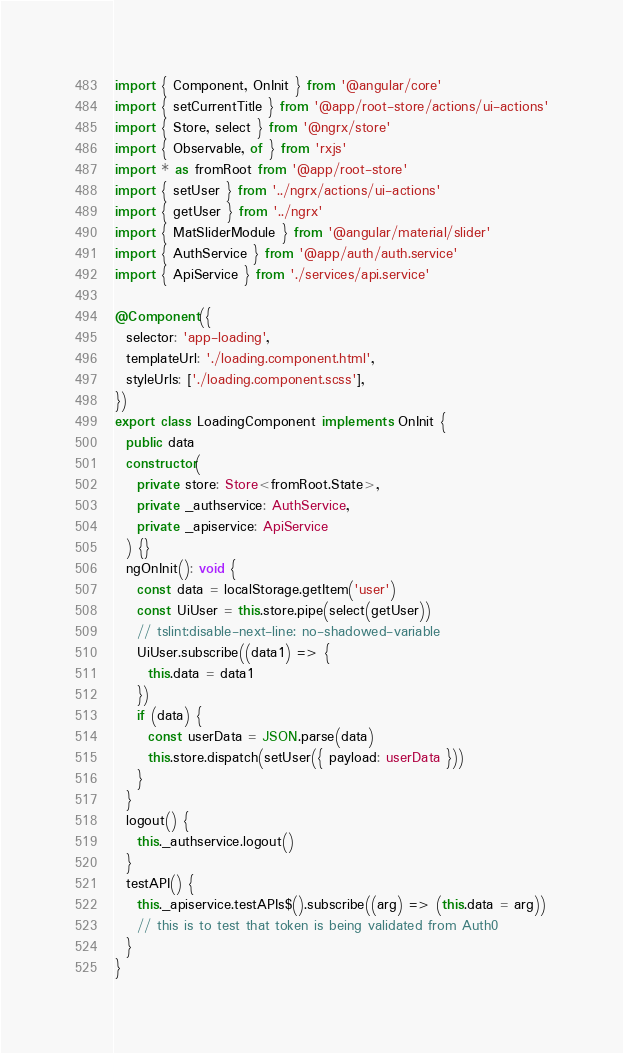Convert code to text. <code><loc_0><loc_0><loc_500><loc_500><_TypeScript_>import { Component, OnInit } from '@angular/core'
import { setCurrentTitle } from '@app/root-store/actions/ui-actions'
import { Store, select } from '@ngrx/store'
import { Observable, of } from 'rxjs'
import * as fromRoot from '@app/root-store'
import { setUser } from '../ngrx/actions/ui-actions'
import { getUser } from '../ngrx'
import { MatSliderModule } from '@angular/material/slider'
import { AuthService } from '@app/auth/auth.service'
import { ApiService } from './services/api.service'

@Component({
  selector: 'app-loading',
  templateUrl: './loading.component.html',
  styleUrls: ['./loading.component.scss'],
})
export class LoadingComponent implements OnInit {
  public data
  constructor(
    private store: Store<fromRoot.State>,
    private _authservice: AuthService,
    private _apiservice: ApiService
  ) {}
  ngOnInit(): void {
    const data = localStorage.getItem('user')
    const UiUser = this.store.pipe(select(getUser))
    // tslint:disable-next-line: no-shadowed-variable
    UiUser.subscribe((data1) => {
      this.data = data1
    })
    if (data) {
      const userData = JSON.parse(data)
      this.store.dispatch(setUser({ payload: userData }))
    }
  }
  logout() {
    this._authservice.logout()
  }
  testAPI() {
    this._apiservice.testAPIs$().subscribe((arg) => (this.data = arg))
    // this is to test that token is being validated from Auth0
  }
}
</code> 